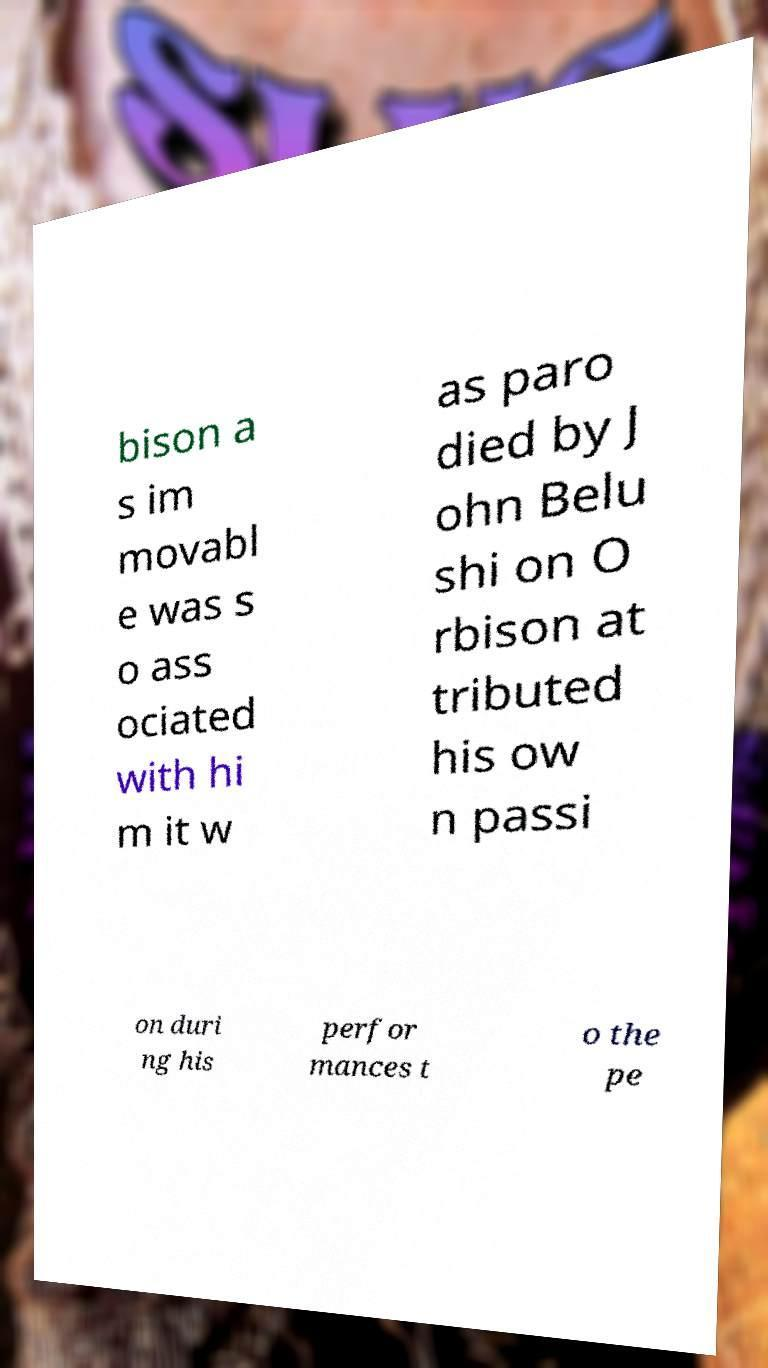Could you extract and type out the text from this image? bison a s im movabl e was s o ass ociated with hi m it w as paro died by J ohn Belu shi on O rbison at tributed his ow n passi on duri ng his perfor mances t o the pe 